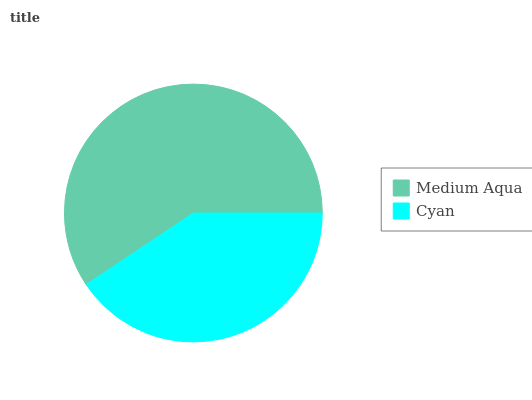Is Cyan the minimum?
Answer yes or no. Yes. Is Medium Aqua the maximum?
Answer yes or no. Yes. Is Cyan the maximum?
Answer yes or no. No. Is Medium Aqua greater than Cyan?
Answer yes or no. Yes. Is Cyan less than Medium Aqua?
Answer yes or no. Yes. Is Cyan greater than Medium Aqua?
Answer yes or no. No. Is Medium Aqua less than Cyan?
Answer yes or no. No. Is Medium Aqua the high median?
Answer yes or no. Yes. Is Cyan the low median?
Answer yes or no. Yes. Is Cyan the high median?
Answer yes or no. No. Is Medium Aqua the low median?
Answer yes or no. No. 